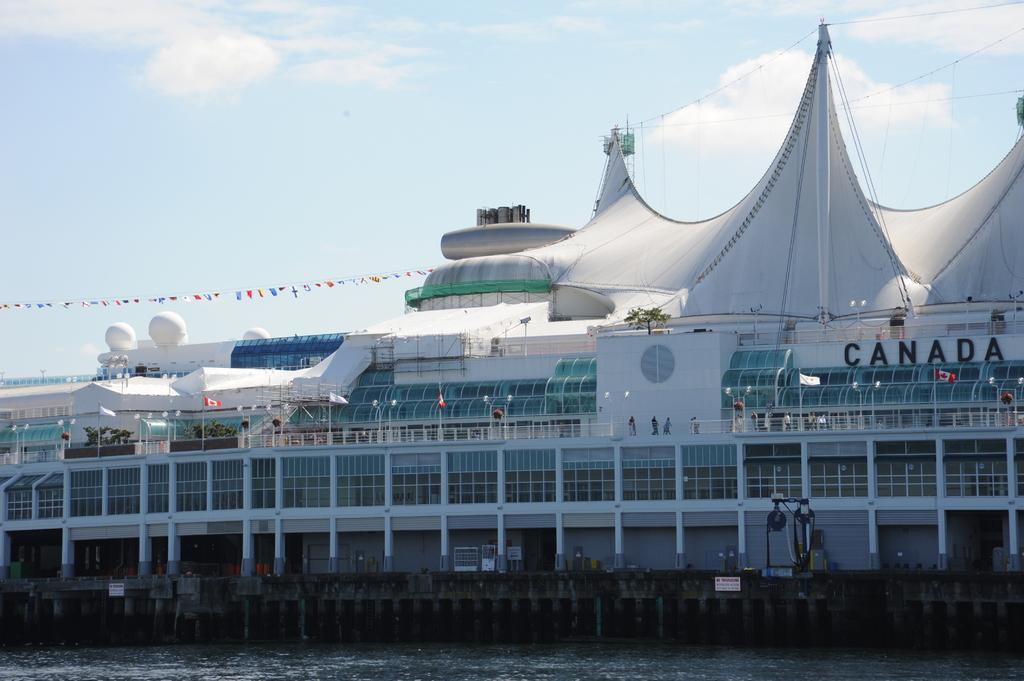Could you give a brief overview of what you see in this image? In this image I can see the ship on the water. I can see few people in the ship. In the background I can see the clouds and the sky. 